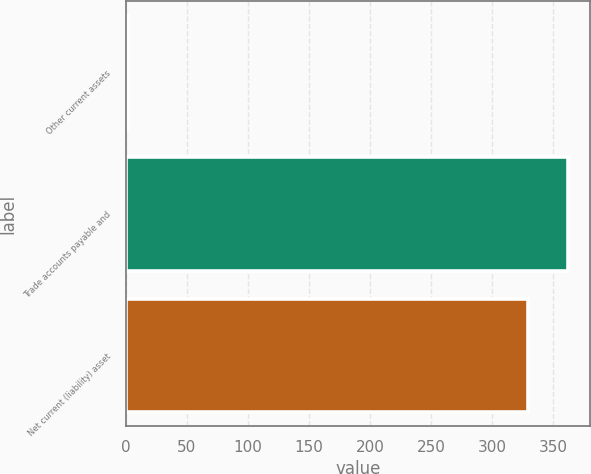Convert chart. <chart><loc_0><loc_0><loc_500><loc_500><bar_chart><fcel>Other current assets<fcel>Trade accounts payable and<fcel>Net current (liability) asset<nl><fcel>2<fcel>361.9<fcel>329<nl></chart> 